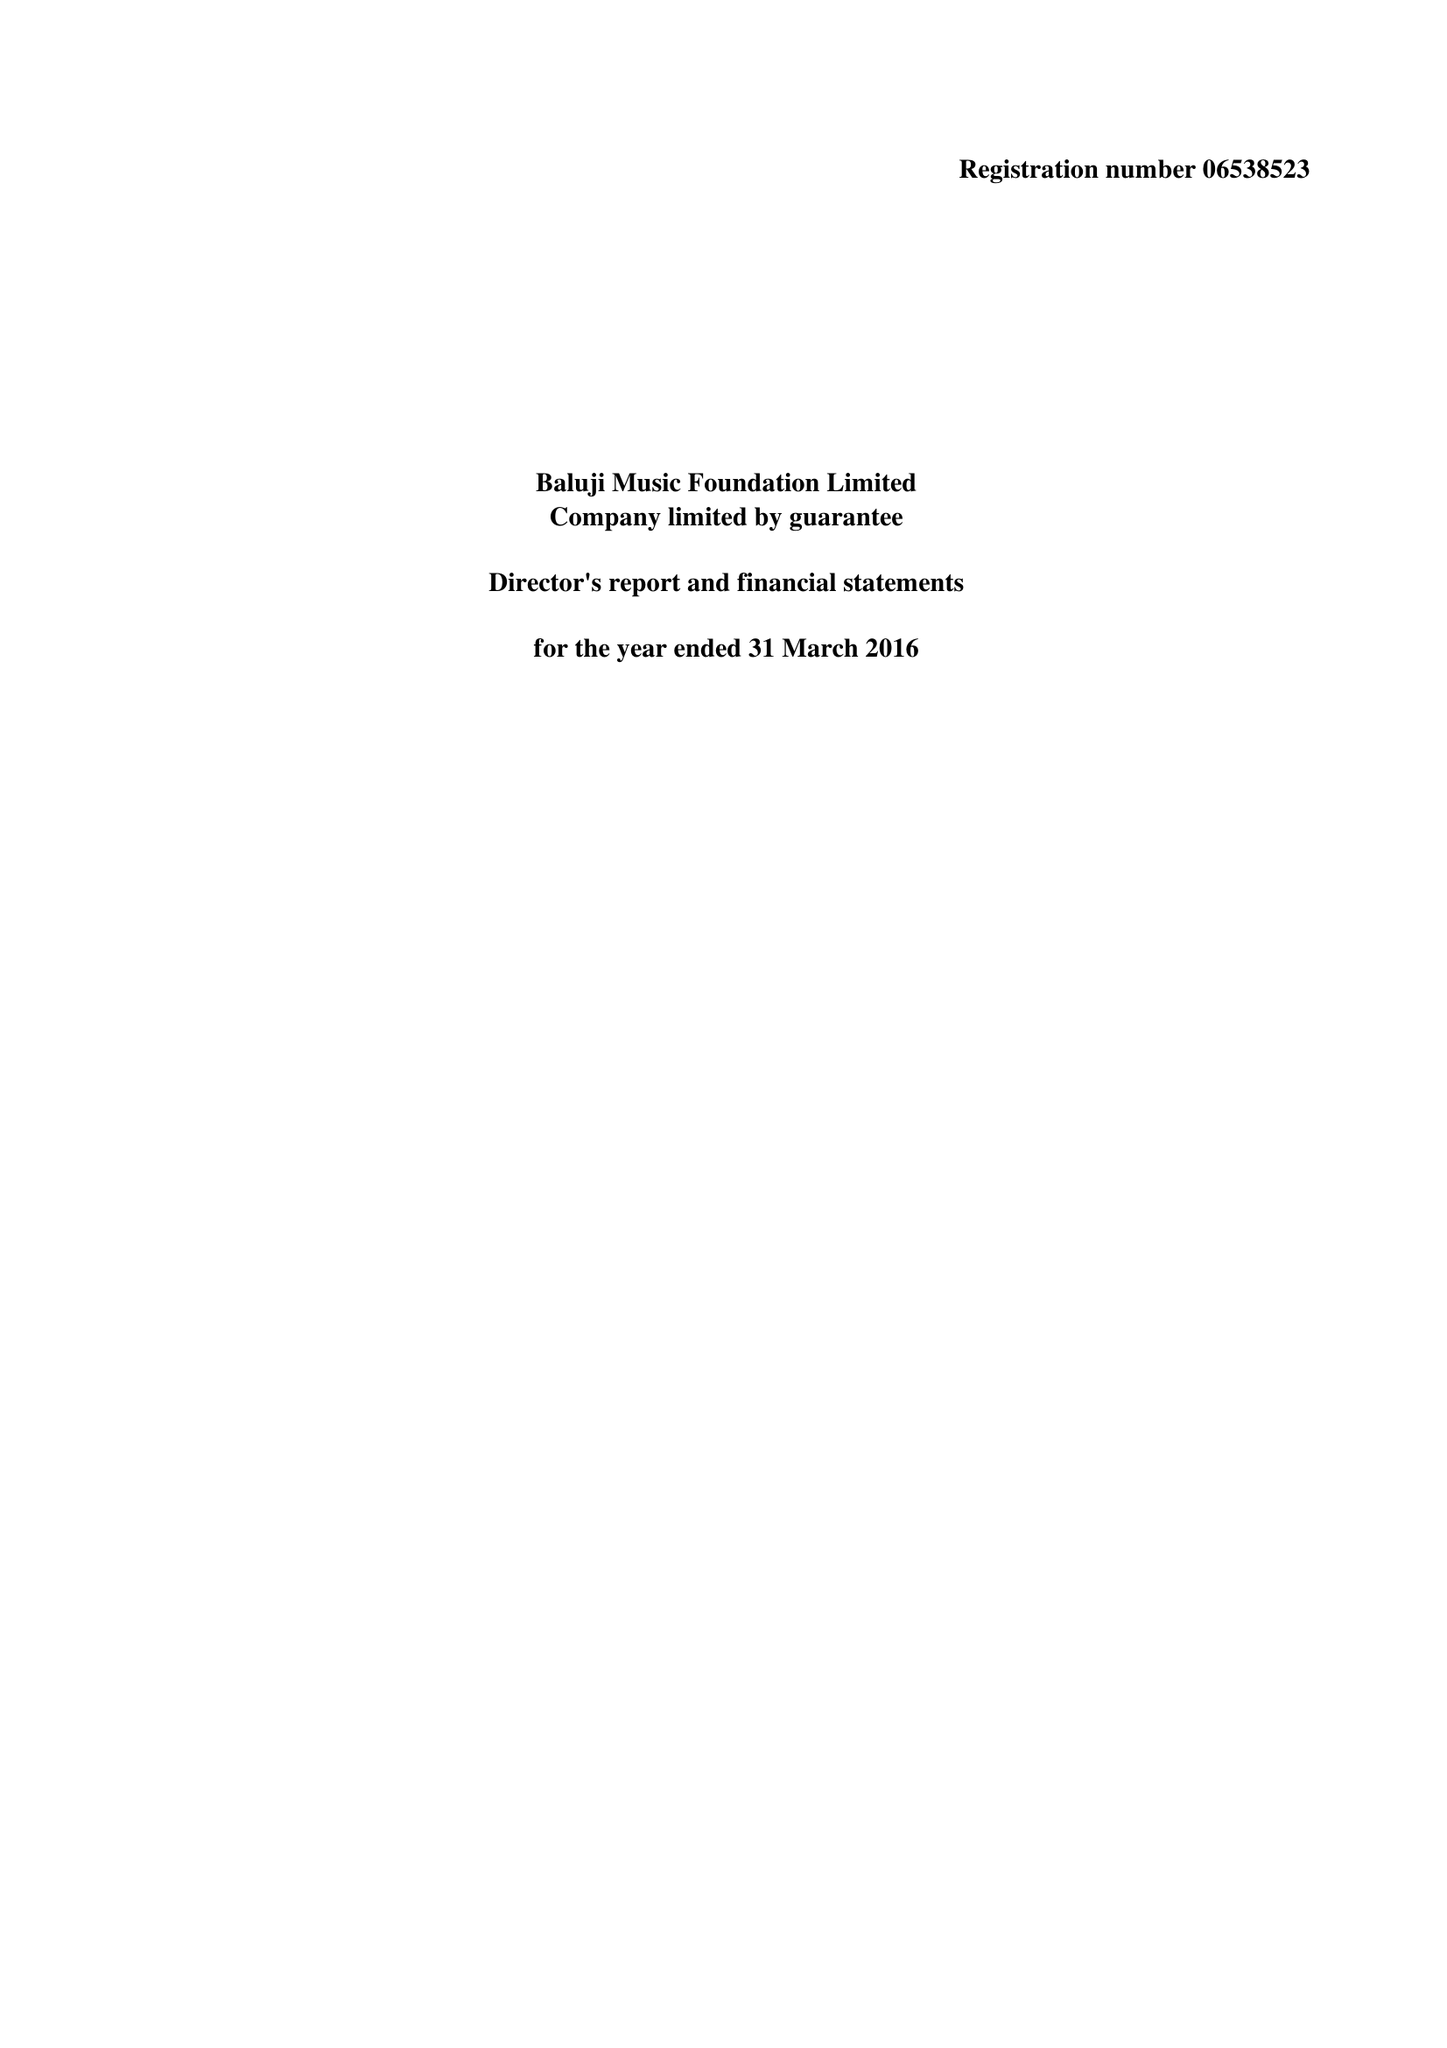What is the value for the report_date?
Answer the question using a single word or phrase. 2016-03-31 